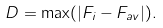<formula> <loc_0><loc_0><loc_500><loc_500>D = \max ( | F _ { i } - F _ { a v } | ) .</formula> 